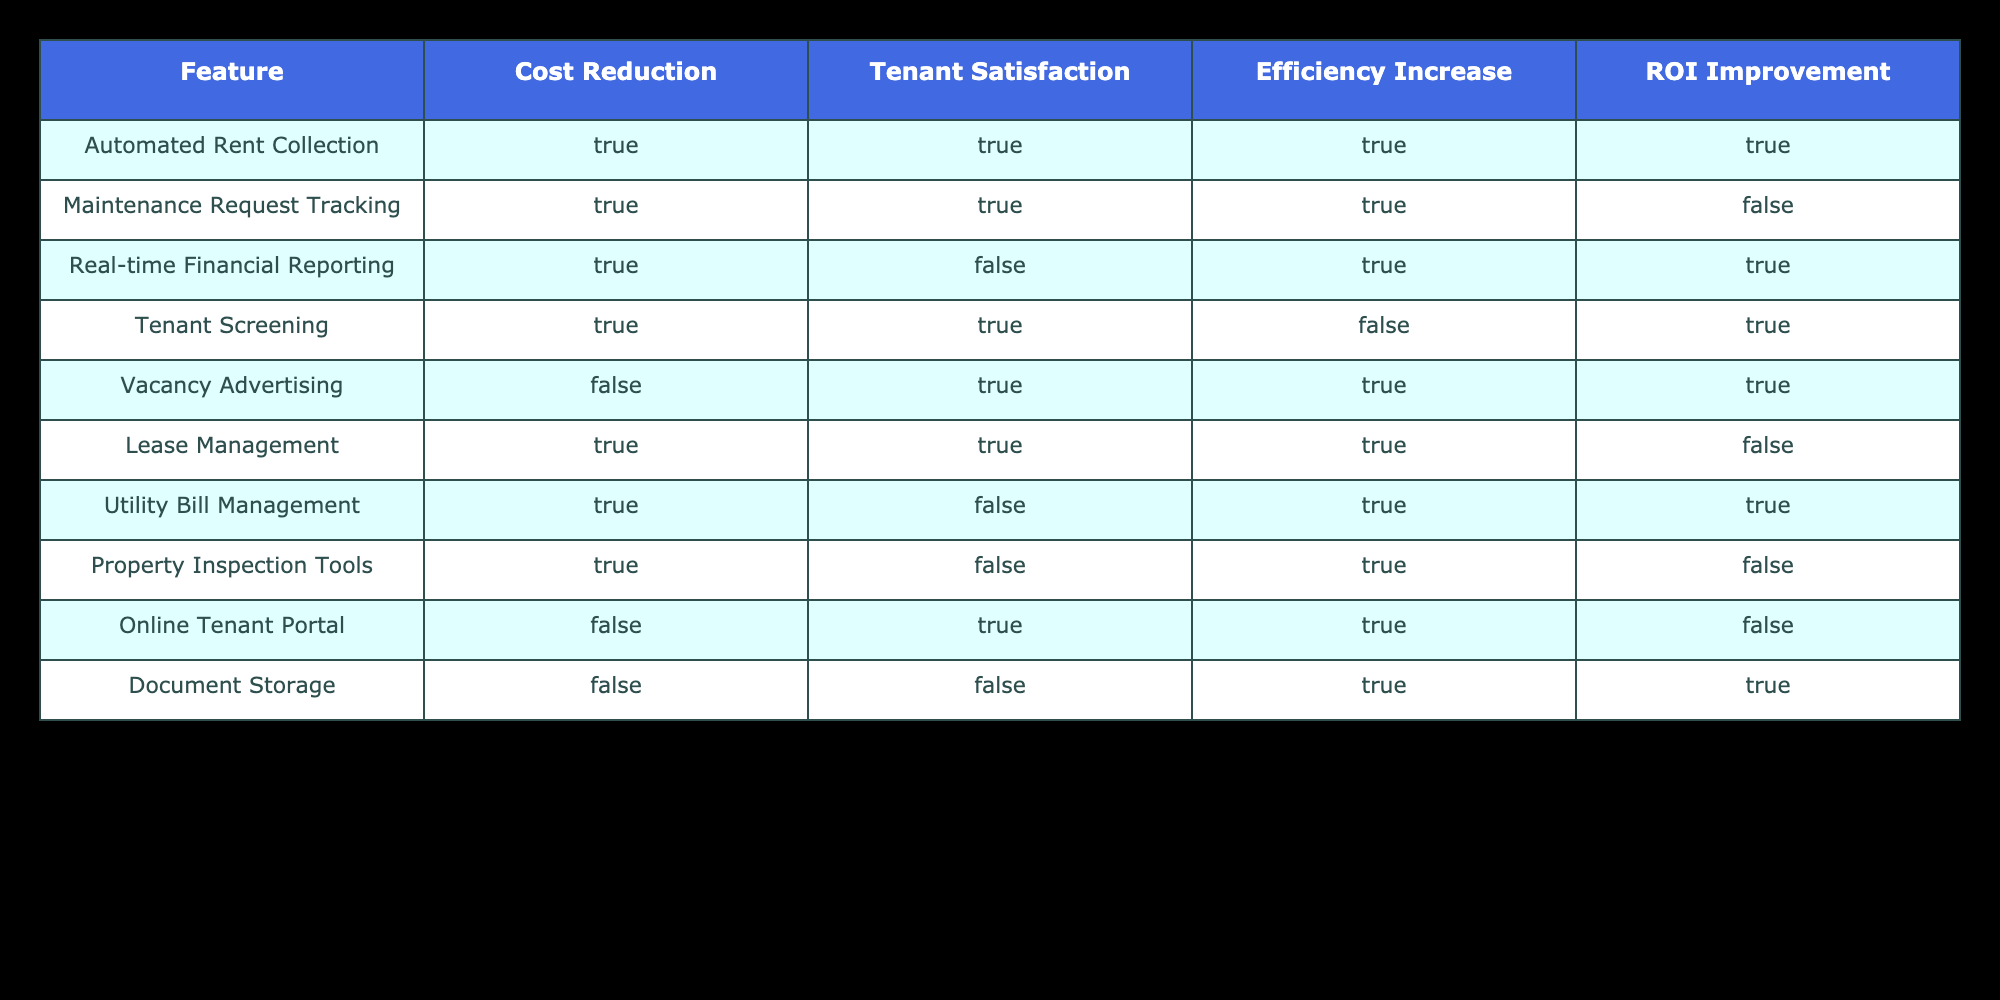What are the benefits of Automated Rent Collection? The table shows that Automated Rent Collection leads to cost reduction, tenant satisfaction, efficiency increase, and ROI improvement. All columns under this feature indicate "TRUE".
Answer: All benefits Is there any feature that does not improve ROI? Looking at the table, Maintenance Request Tracking, Lease Management, and Property Inspection Tools show "FALSE" in the ROI Improvement column, indicating that these features do not enhance ROI.
Answer: Yes, three features Which feature has the highest number of benefits related to Tenant Satisfaction and Efficiency Increase? Tenant Screening has two benefits (TRUE values) under Tenant Satisfaction and Efficiency Increase, while Automated Rent Collection has the same. However, no feature has more than these two benefits for both criteria.
Answer: Tenant Screening and Automated Rent Collection Are there any features that do not contribute to cost reduction? The table identifies Vacancy Advertising, Online Tenant Portal, and Document Storage as having "FALSE" for cost reduction, indicating they do not contribute in this aspect.
Answer: Yes, three features Which feature combines efficiency increase and tenant satisfaction without improving ROI? The feature Lease Management satisfies this condition, as it has TRUE for both tenant satisfaction and efficiency increase, but FALSE for ROI improvement.
Answer: Lease Management Which features increase efficiency but do not improve ROI? Looking through the table, Maintenance Request Tracking, Utility Bill Management, and Property Inspection Tools all have TRUE for efficiency increase, yet FALSE for ROI improvement.
Answer: Three features: Maintenance Request Tracking, Utility Bill Management, Property Inspection Tools What percentage of features improve tenant satisfaction? In total, there are 10 features listed. Out of these, 6 features show "TRUE" for tenant satisfaction, which calculates to 60%.
Answer: 60% What is the sum of features that reduce costs and increase efficiency? The features that show "TRUE" for both cost reduction and efficiency increase are Automated Rent Collection, Maintenance Request Tracking, Tenant Screening, and Utility Bill Management, making a total of 4 features.
Answer: 4 features 